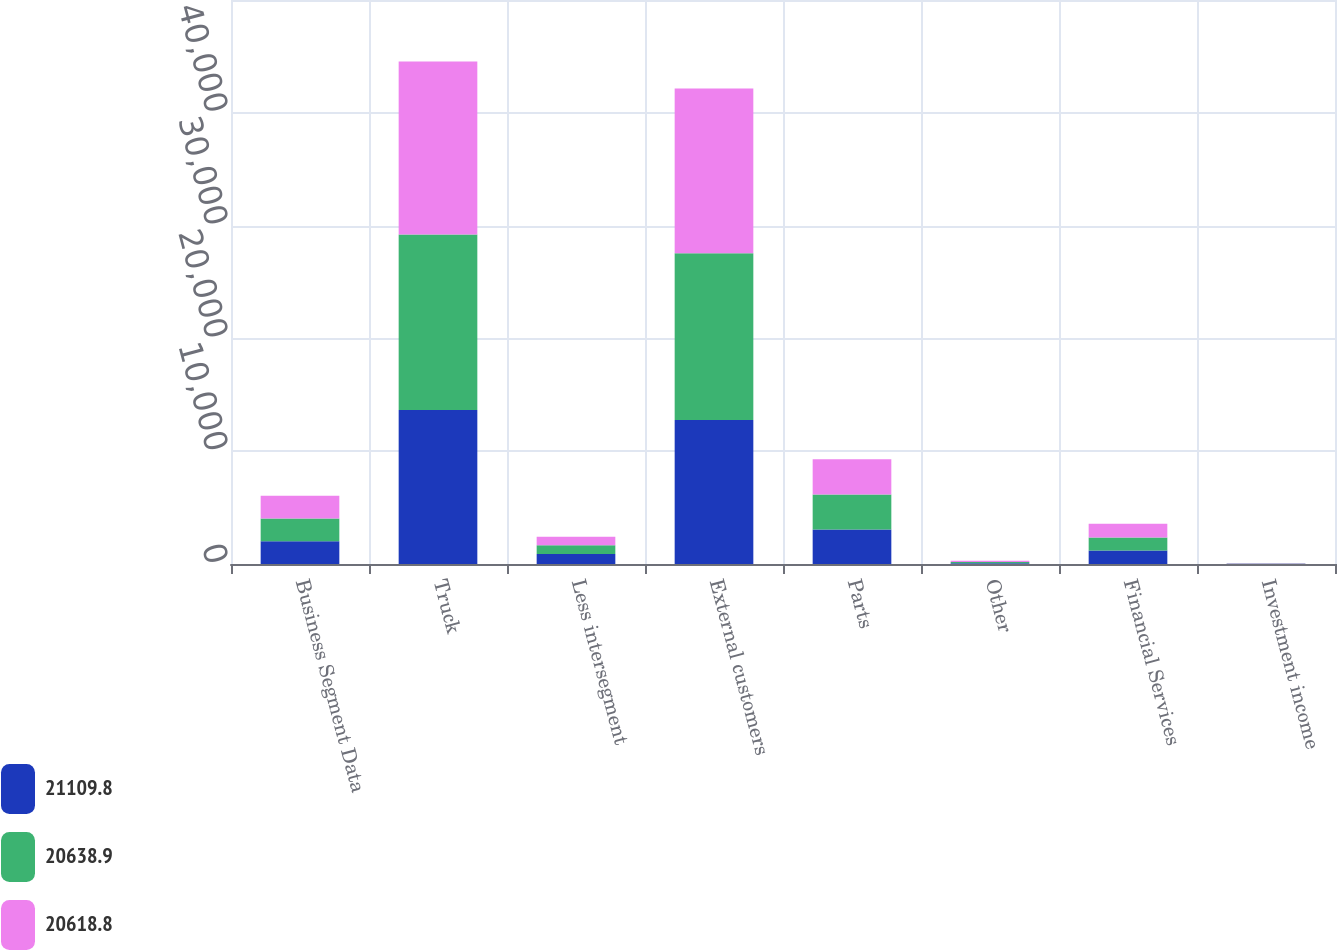<chart> <loc_0><loc_0><loc_500><loc_500><stacked_bar_chart><ecel><fcel>Business Segment Data<fcel>Truck<fcel>Less intersegment<fcel>External customers<fcel>Parts<fcel>Other<fcel>Financial Services<fcel>Investment income<nl><fcel>21109.8<fcel>2016<fcel>13652.7<fcel>885.4<fcel>12767.3<fcel>3052.9<fcel>73.6<fcel>1186.7<fcel>27.6<nl><fcel>20638.9<fcel>2015<fcel>15568.6<fcel>786.1<fcel>14782.5<fcel>3104.7<fcel>100.2<fcel>1172.3<fcel>21.8<nl><fcel>20618.8<fcel>2014<fcel>15330.4<fcel>736.4<fcel>14594<fcel>3125.9<fcel>121.3<fcel>1204.2<fcel>22.3<nl></chart> 